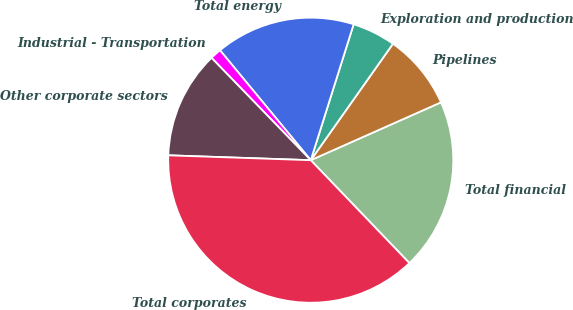Convert chart. <chart><loc_0><loc_0><loc_500><loc_500><pie_chart><fcel>Total financial<fcel>Pipelines<fcel>Exploration and production<fcel>Total energy<fcel>Industrial - Transportation<fcel>Other corporate sectors<fcel>Total corporates<nl><fcel>19.49%<fcel>8.56%<fcel>4.92%<fcel>15.85%<fcel>1.27%<fcel>12.2%<fcel>37.71%<nl></chart> 